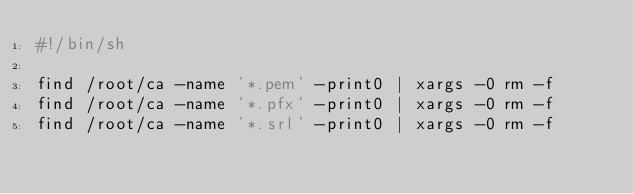Convert code to text. <code><loc_0><loc_0><loc_500><loc_500><_Bash_>#!/bin/sh

find /root/ca -name '*.pem' -print0 | xargs -0 rm -f
find /root/ca -name '*.pfx' -print0 | xargs -0 rm -f
find /root/ca -name '*.srl' -print0 | xargs -0 rm -f
</code> 